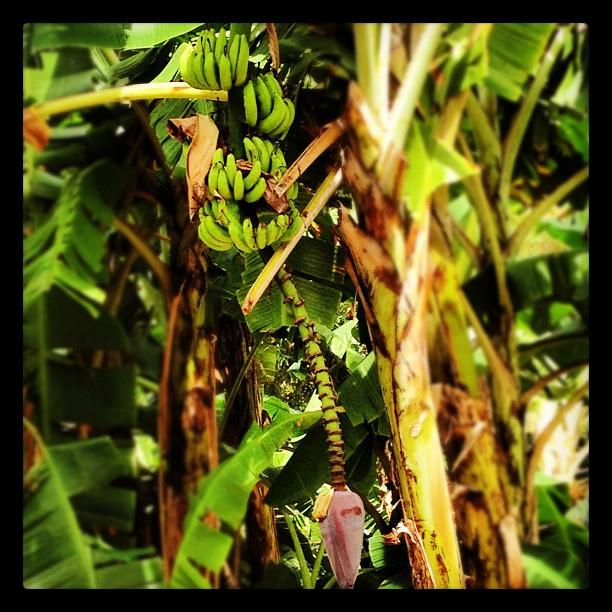Why are the bananas green?

Choices:
A) stained
B) ripe
C) painted
D) unripe unripe 